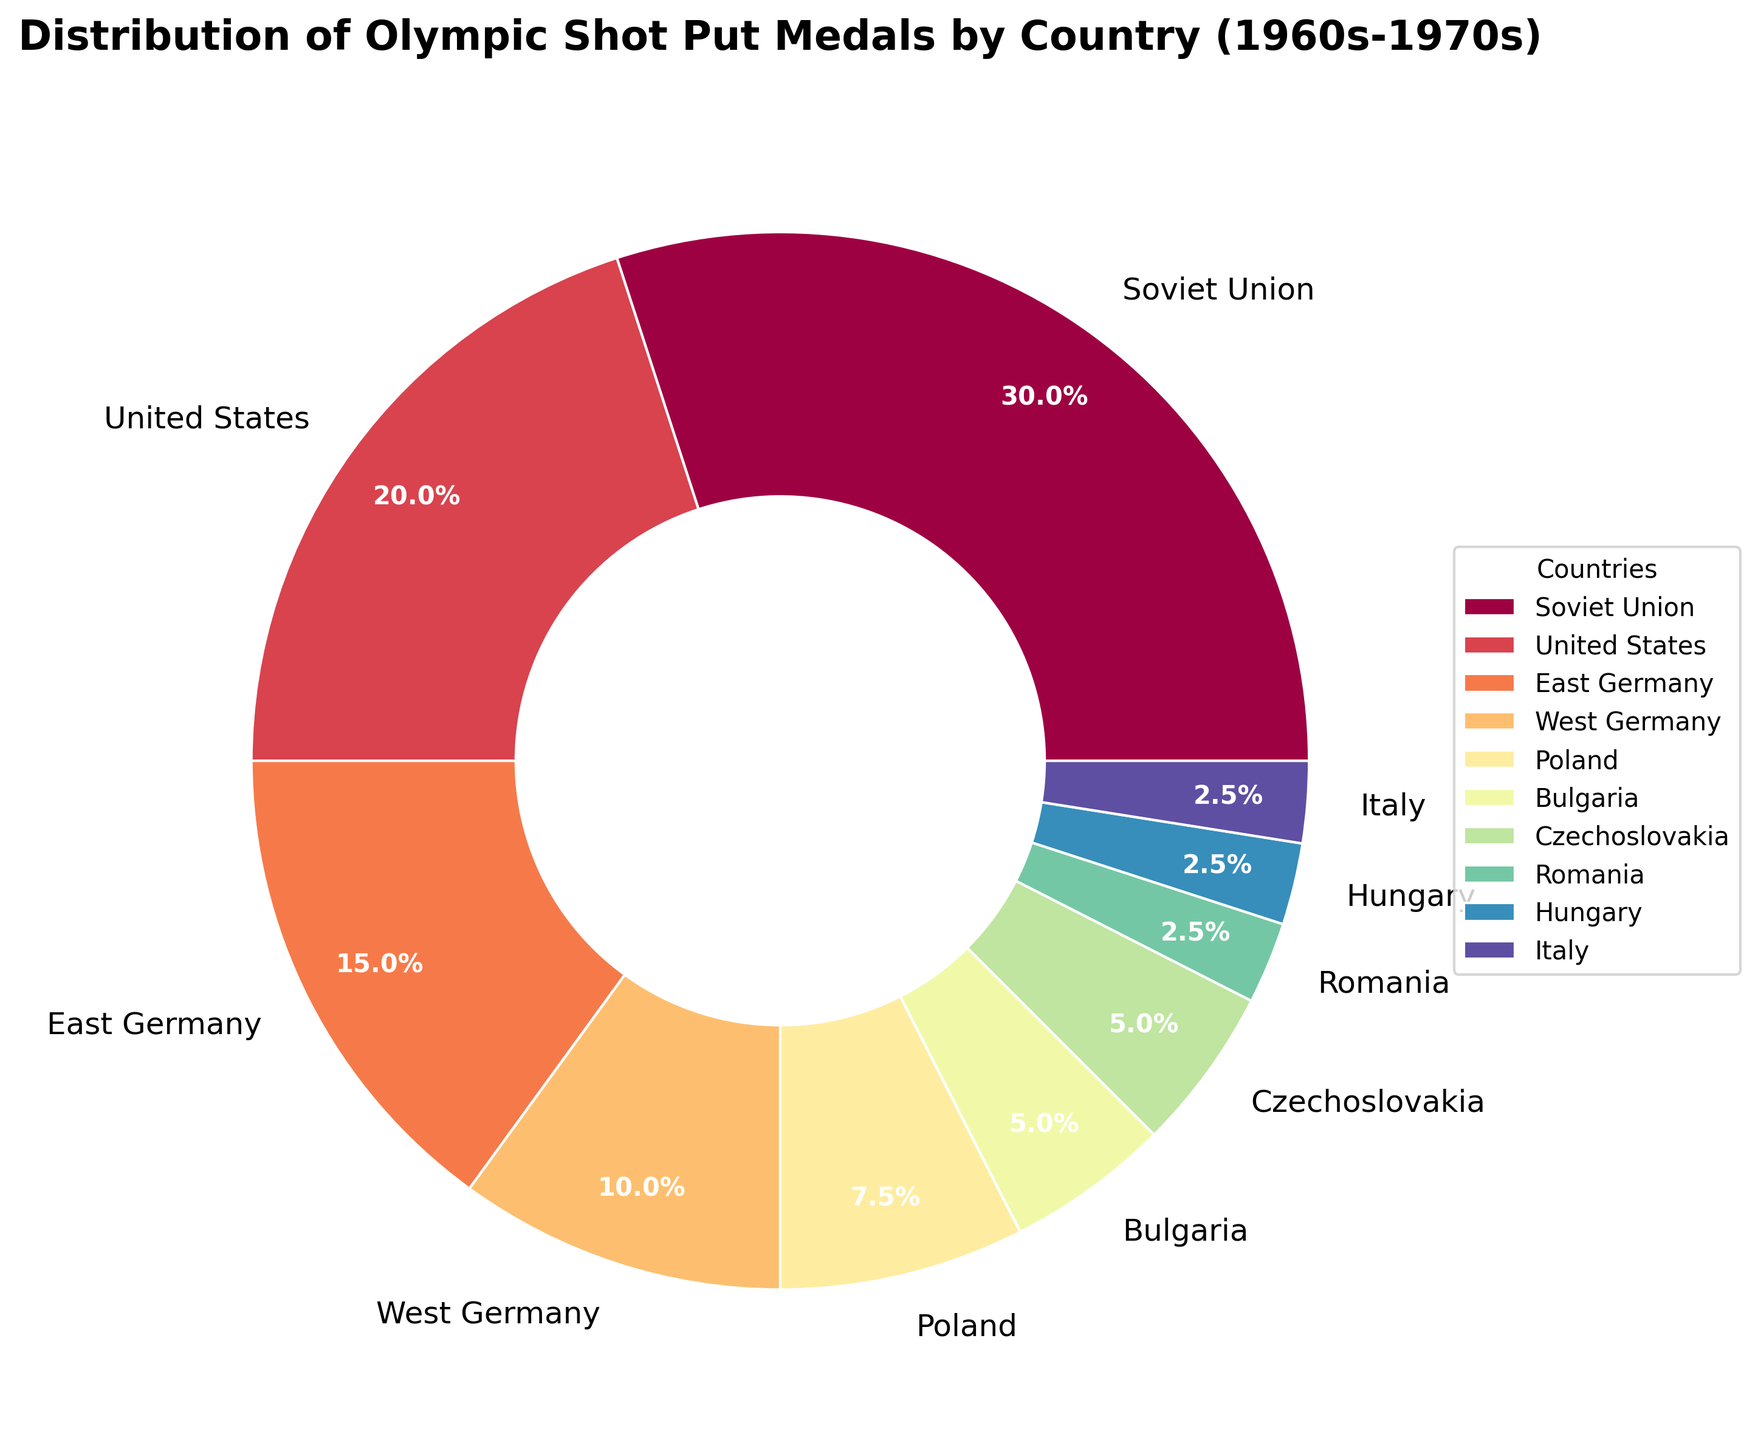Which country has the highest medal count? The Soviet Union occupies the largest wedge in the pie chart with a label indicating 12 medals.
Answer: Soviet Union How many more medals did the Soviet Union win compared to Bulgaria? The Soviet Union won 12 medals and Bulgaria won 2. Subtracting the two gives 12 - 2 = 10.
Answer: 10 Which two countries have an equal medal count? Bulgaria and Czechoslovakia each have a wedge labeled with 2 medals.
Answer: Bulgaria and Czechoslovakia What fraction of the total medals was won by the United States, and how is it visually represented? The United States won 8 medals out of a total of (12 + 8 + 6 + 4 + 3 + 2 + 2 + 1 + 1 + 1 = 40) medals. The fraction is 8/40, which simplifies to 1/5 or 20%, represented by a segment taking up 20% of the pie chart.
Answer: 1/5, 20% Compare the medal count between East Germany and West Germany. Which one is higher and by how much? East Germany won 6 medals, and West Germany won 4 medals. The difference is 6 - 4 = 2, with East Germany having 2 more medals.
Answer: East Germany, 2 What percentage of the total medals was won by Eastern European countries (Soviet Union, East Germany, Poland, Bulgaria, Czechoslovakia, Romania, Hungary)? Adding the medal counts of Eastern European countries: 12 (Soviet Union) + 6 (East Germany) + 3 (Poland) + 2 (Bulgaria) + 2 (Czechoslovakia) + 1 (Romania) + 1 (Hungary) = 27. The total medal count is 40. Therefore, the percentage is (27/40) * 100 = 67.5%.
Answer: 67.5% Which three countries have the smallest medal count and what is their combined total? Romania, Hungary, and Italy each have 1 medal. Their combined total is 1 + 1 + 1 = 3.
Answer: Romania, Hungary, Italy, 3 If you combined the medal counts of East and West Germany, what would their total be, and how would it compare to the Soviet Union? East Germany has 6 medals, and West Germany has 4. Combined, they have 6 + 4 = 10 medals. The Soviet Union has 12 medals, so the combined total of East and West Germany is 2 medals less.
Answer: 10, 2 less What is the average number of medals won by each country? The total number of medals is 40, and there are 10 countries. The average is 40/10 = 4.
Answer: 4 